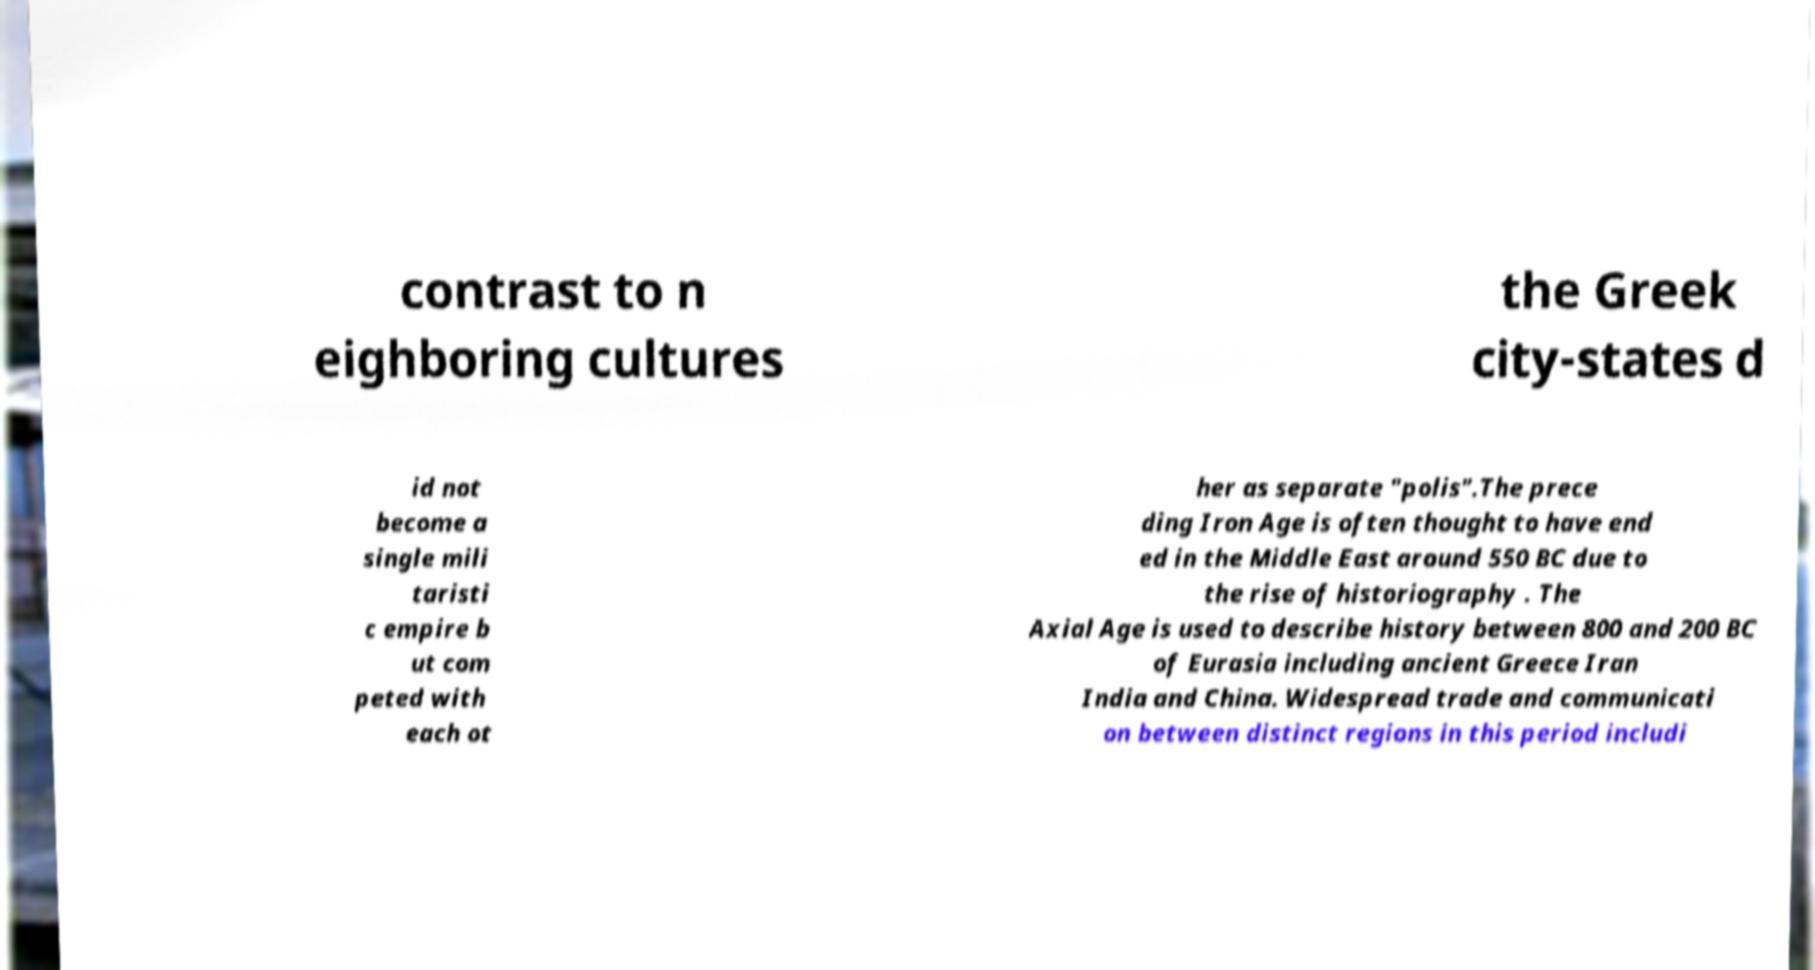Can you accurately transcribe the text from the provided image for me? contrast to n eighboring cultures the Greek city-states d id not become a single mili taristi c empire b ut com peted with each ot her as separate "polis".The prece ding Iron Age is often thought to have end ed in the Middle East around 550 BC due to the rise of historiography . The Axial Age is used to describe history between 800 and 200 BC of Eurasia including ancient Greece Iran India and China. Widespread trade and communicati on between distinct regions in this period includi 